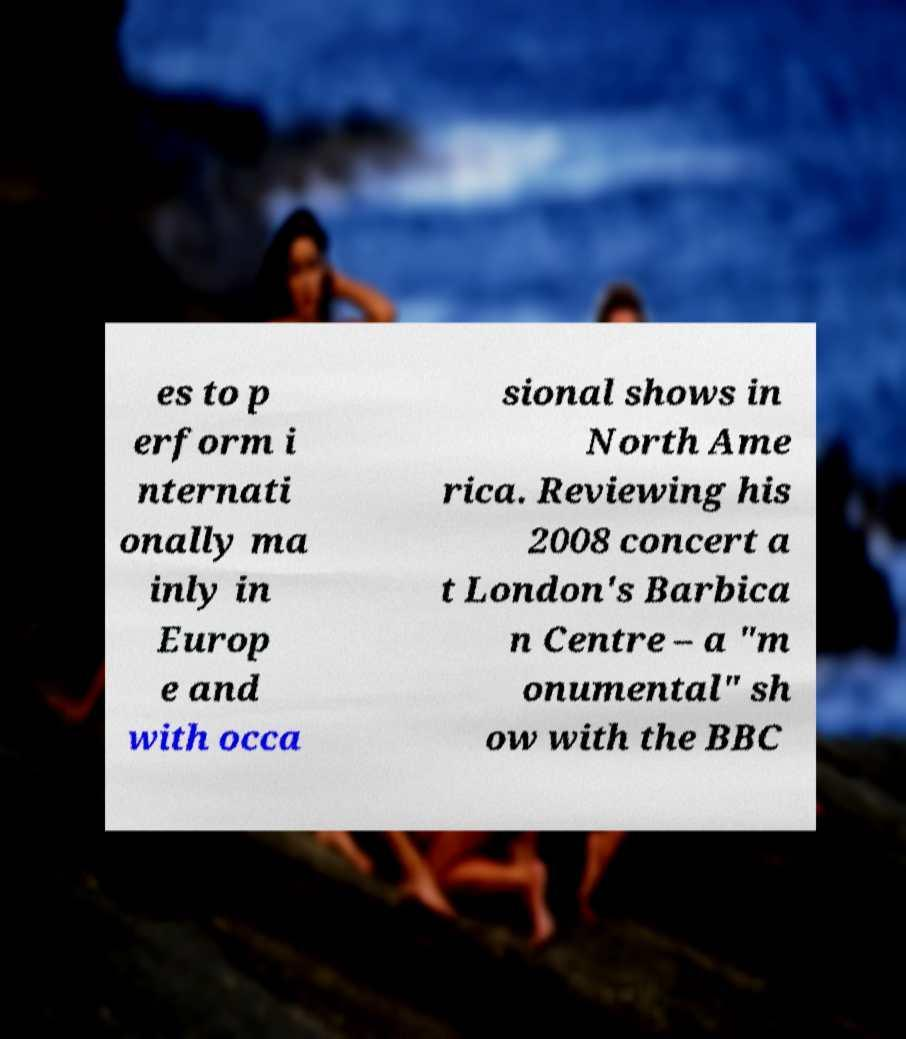Can you read and provide the text displayed in the image?This photo seems to have some interesting text. Can you extract and type it out for me? es to p erform i nternati onally ma inly in Europ e and with occa sional shows in North Ame rica. Reviewing his 2008 concert a t London's Barbica n Centre – a "m onumental" sh ow with the BBC 